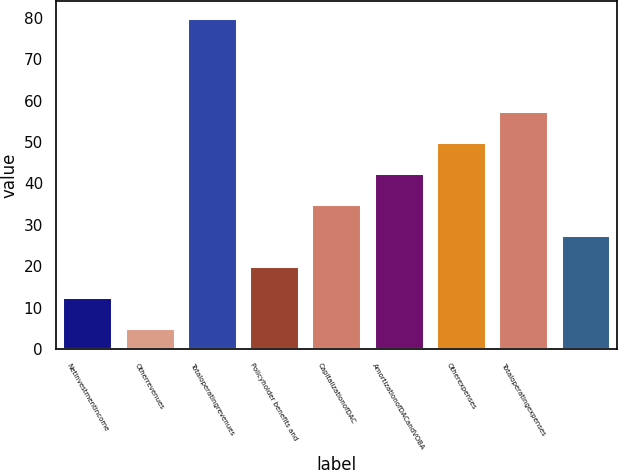Convert chart. <chart><loc_0><loc_0><loc_500><loc_500><bar_chart><fcel>Netinvestmentincome<fcel>Otherrevenues<fcel>Totaloperatingrevenues<fcel>Policyholder benefits and<fcel>CapitalizationofDAC<fcel>AmortizationofDACandVOBA<fcel>Otherexpenses<fcel>Totaloperatingexpenses<fcel>Unnamed: 8<nl><fcel>12.5<fcel>5<fcel>80<fcel>20<fcel>35<fcel>42.5<fcel>50<fcel>57.5<fcel>27.5<nl></chart> 